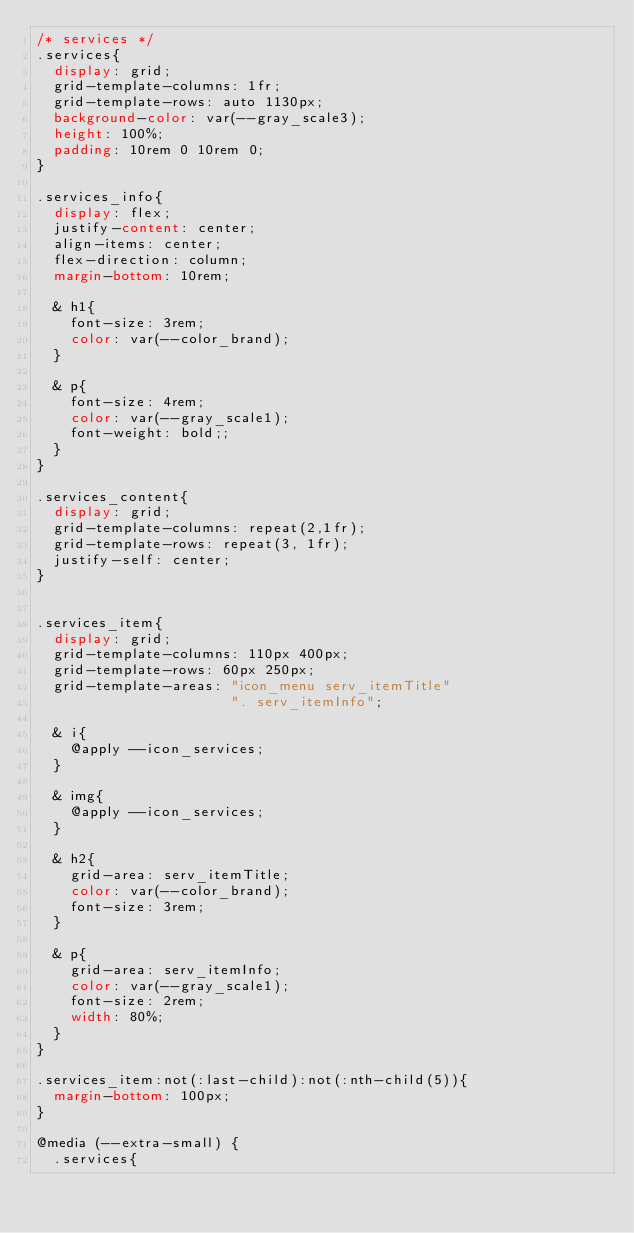<code> <loc_0><loc_0><loc_500><loc_500><_CSS_>/* services */
.services{
  display: grid;
  grid-template-columns: 1fr;
  grid-template-rows: auto 1130px;
  background-color: var(--gray_scale3);
  height: 100%;
  padding: 10rem 0 10rem 0;
}

.services_info{
  display: flex;
  justify-content: center;
  align-items: center;
  flex-direction: column;
  margin-bottom: 10rem;

  & h1{
    font-size: 3rem;
    color: var(--color_brand);
  }

  & p{
    font-size: 4rem;
    color: var(--gray_scale1);
    font-weight: bold;;
  }
}

.services_content{
  display: grid;
  grid-template-columns: repeat(2,1fr);
  grid-template-rows: repeat(3, 1fr);
  justify-self: center;
}


.services_item{
  display: grid;
  grid-template-columns: 110px 400px;
  grid-template-rows: 60px 250px;
  grid-template-areas: "icon_menu serv_itemTitle"
                       ". serv_itemInfo";

  & i{
    @apply --icon_services;
  }

  & img{
    @apply --icon_services;
  }

  & h2{
    grid-area: serv_itemTitle;
    color: var(--color_brand);
    font-size: 3rem;
  }

  & p{
    grid-area: serv_itemInfo;
    color: var(--gray_scale1);
    font-size: 2rem;
    width: 80%;
  }
}

.services_item:not(:last-child):not(:nth-child(5)){
  margin-bottom: 100px;
}

@media (--extra-small) {
  .services{</code> 